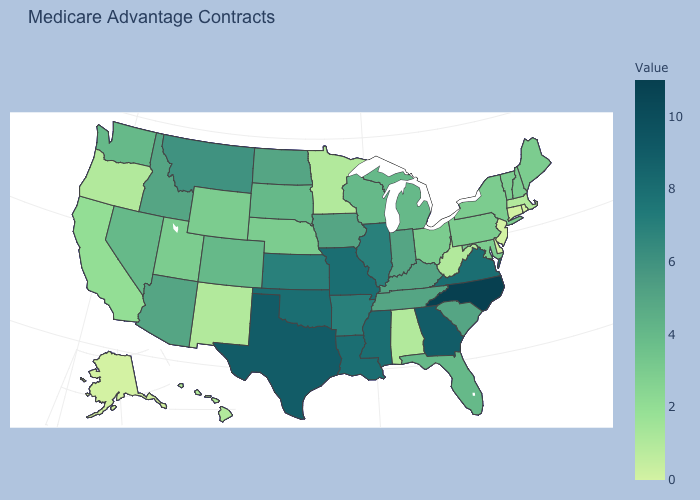Which states have the lowest value in the USA?
Give a very brief answer. Alaska, Connecticut, Delaware, New Jersey, Rhode Island. Is the legend a continuous bar?
Quick response, please. Yes. Among the states that border West Virginia , does Kentucky have the lowest value?
Write a very short answer. No. Does Kansas have a lower value than Wisconsin?
Concise answer only. No. Does Rhode Island have the highest value in the USA?
Write a very short answer. No. 